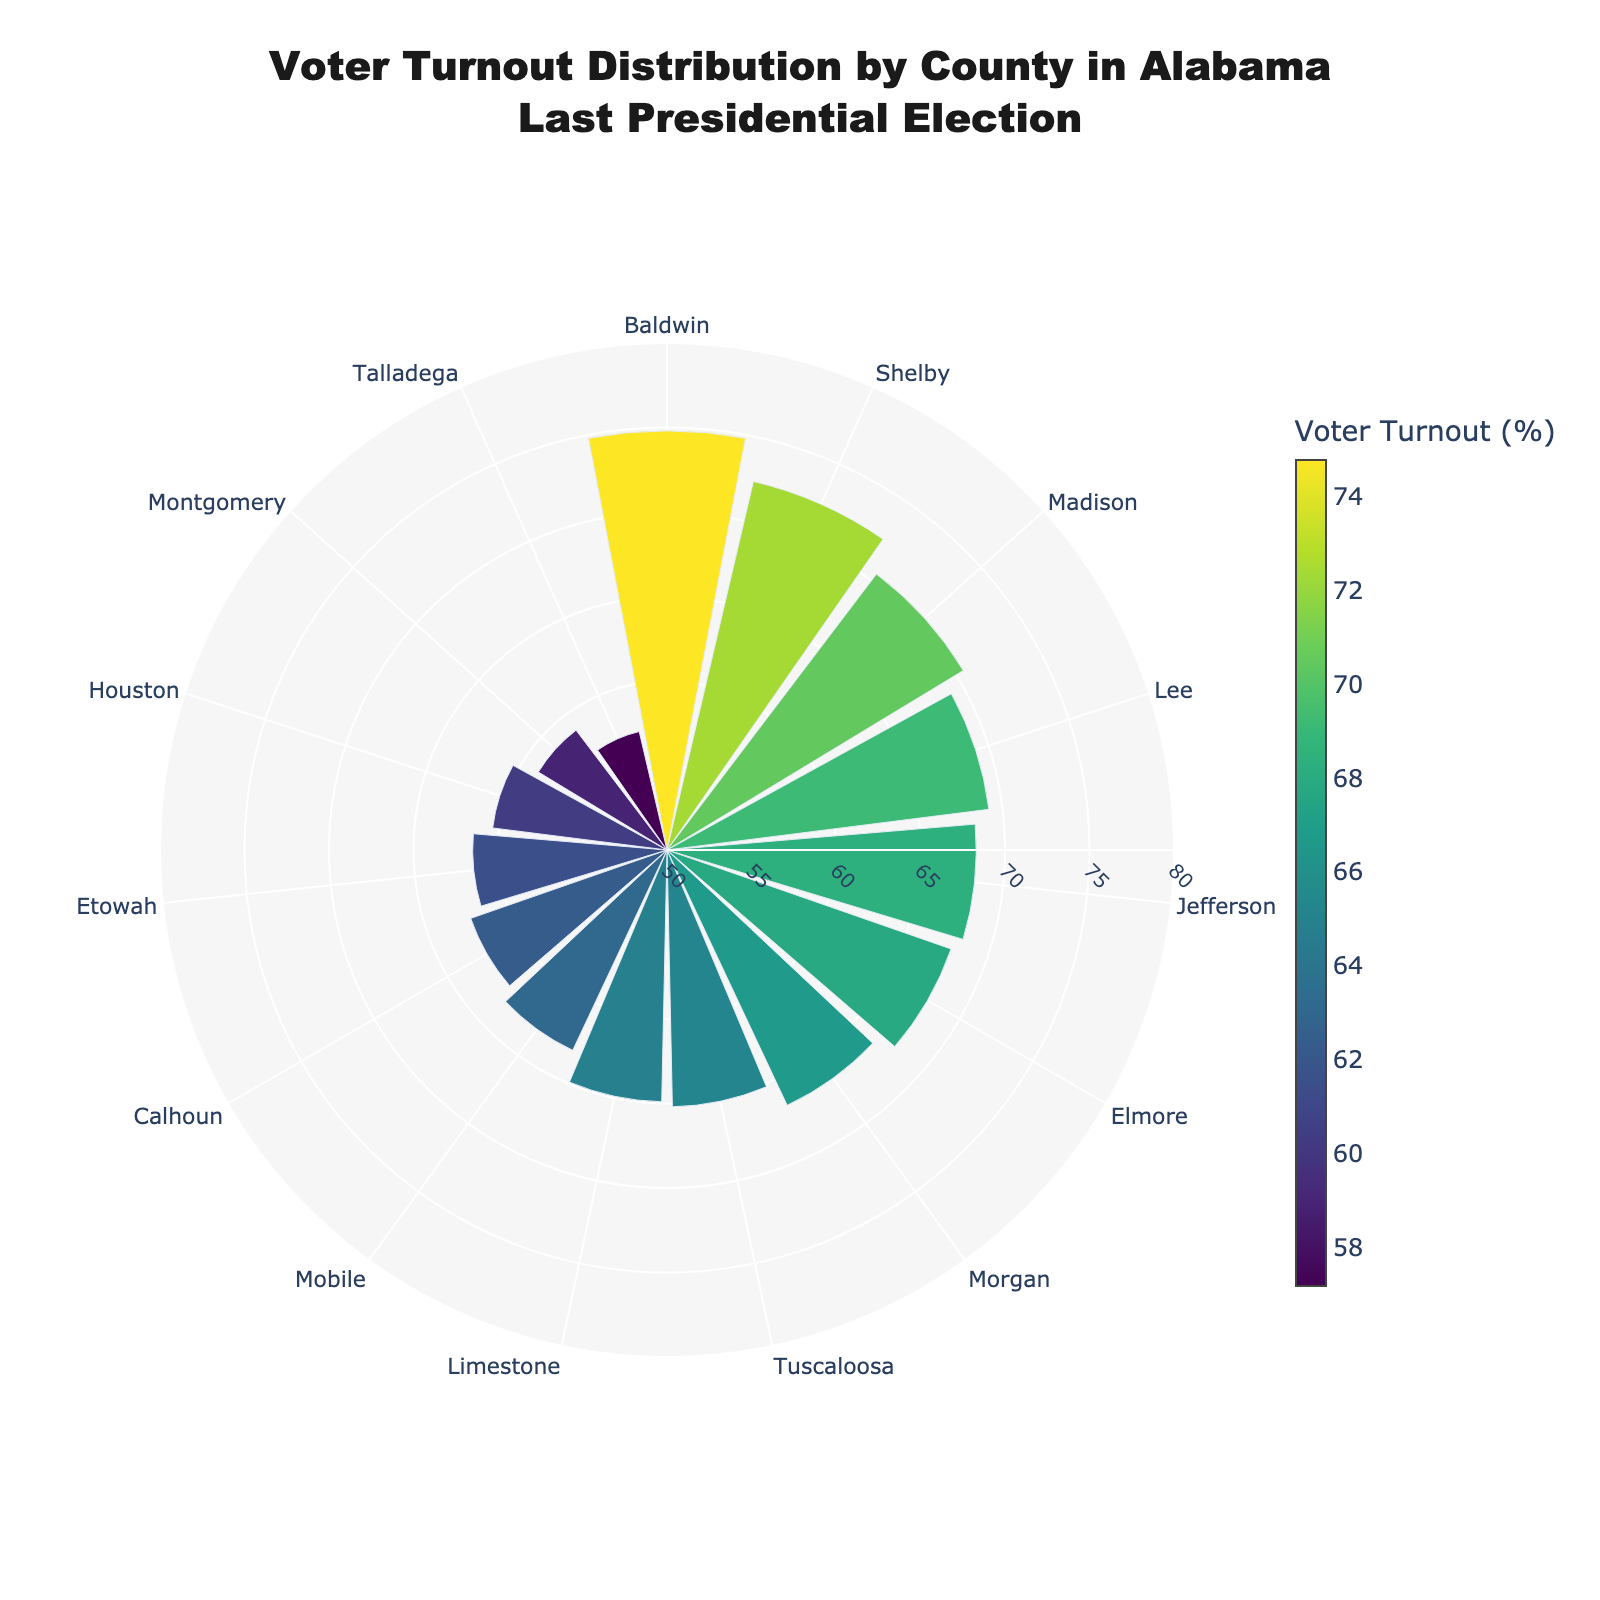What is the county with the highest voter turnout percentage? By looking at the radial bars, Baldwin County reaches the farthest, which indicates the highest turnout of 74.8%.
Answer: Baldwin What is the county with the lowest voter turnout percentage? The radial bar for Talladega County is the shortest, indicating the lowest turnout of 57.2%.
Answer: Talladega Which counties have a voter turnout percentage greater than 70%? The radial bars corresponding to Madison (70.5%), Shelby (72.4%), and Baldwin (74.8%) are beyond the 70% mark.
Answer: Madison, Shelby, Baldwin What is the approximate average voter turnout percentage across all counties? Sum the turnouts: 68.3 + 63.1 + 70.5 + 58.9 + 72.4 + 65.2 + 74.8 + 69.2 + 67.8 + 61.5 + 64.9 + 66.7 + 62.3 + 60.4 + 57.2 = 953.2. Divide by the number of counties (15): 953.2 / 15 ≈ 63.5.
Answer: 63.5 What is the voter turnout range in the figure? The highest turnout is Baldwin with 74.8% and the lowest is Talladega with 57.2%. The range is 74.8 - 57.2 = 17.6%.
Answer: 17.6 Which county has the voter turnout percentage closest to the median? The middle value is 65.2% when the turnouts are listed in order. Tuscaloosa has this value.
Answer: Tuscaloosa What percentage of counties have a voter turnout of 65% or more? Out of 15 counties, Jefferson, Madison, Shelby, Baldwin, Lee, Elmore, Tuscaloosa, Limestone, and Morgan have turnouts ≥65% (9 counties). So, (9/15) * 100 = 60%.
Answer: 60% Which county's voter turnout falls exactly at or above 68% but below 70%? Filtering the percentages within this range (68.0 <= x < 70.0), Elmore (67.8%) and Jefferson (68.3%) fit.
Answer: Jefferson, Elmore Which two counties have the smallest difference in voter turnout percentage? The smallest gap is between Elmore (67.8%) and Jefferson (68.3%), a difference of 0.5 percentage points.
Answer: Elmore, Jefferson What is the total voter turnout percentage for counties with more than 65% turnout? Sum the turnouts for counties >65%: 68.3 + 70.5 + 72.4 + 74.8 + 69.2 + 67.8 + 65.2 + 66.7 = 555.1.
Answer: 555.1 